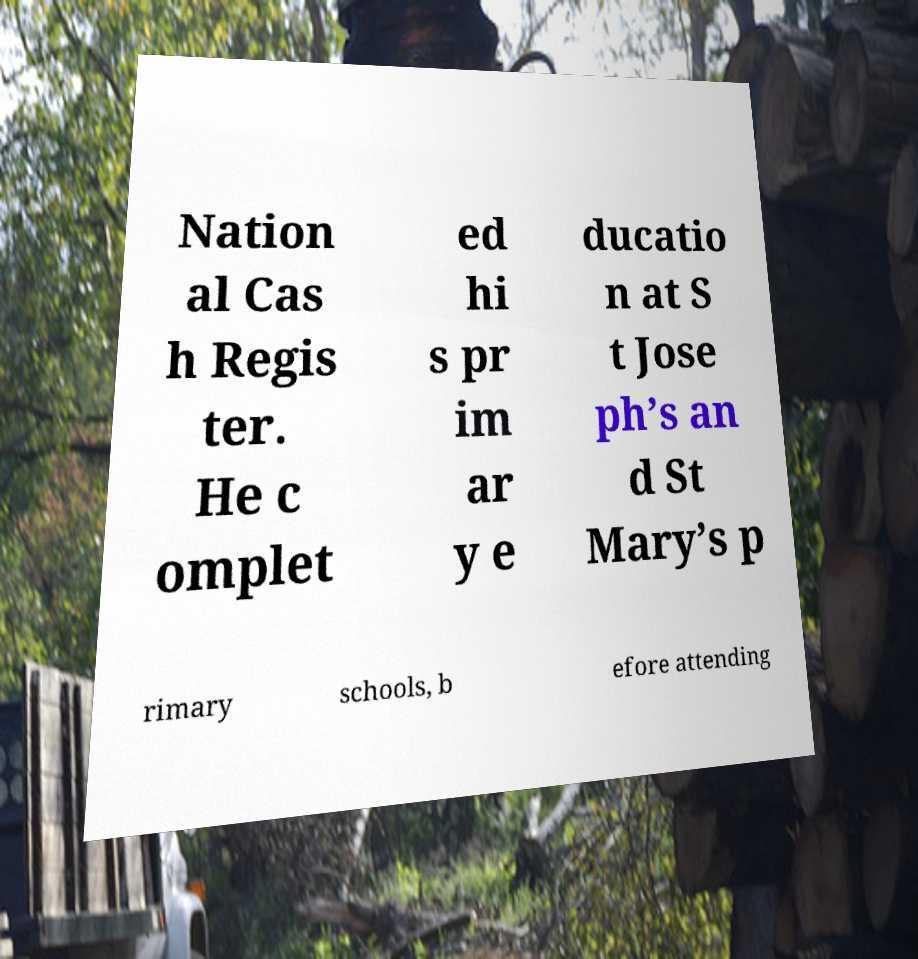Could you extract and type out the text from this image? Nation al Cas h Regis ter. He c omplet ed hi s pr im ar y e ducatio n at S t Jose ph’s an d St Mary’s p rimary schools, b efore attending 